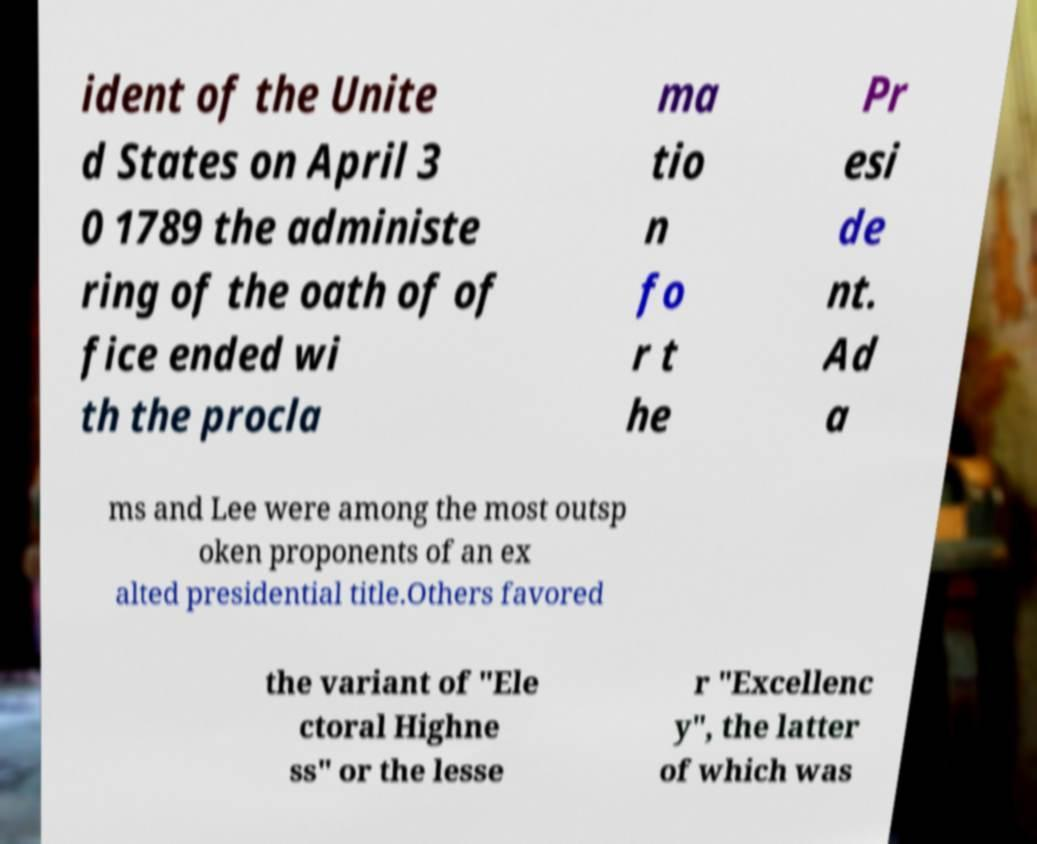For documentation purposes, I need the text within this image transcribed. Could you provide that? ident of the Unite d States on April 3 0 1789 the administe ring of the oath of of fice ended wi th the procla ma tio n fo r t he Pr esi de nt. Ad a ms and Lee were among the most outsp oken proponents of an ex alted presidential title.Others favored the variant of "Ele ctoral Highne ss" or the lesse r "Excellenc y", the latter of which was 